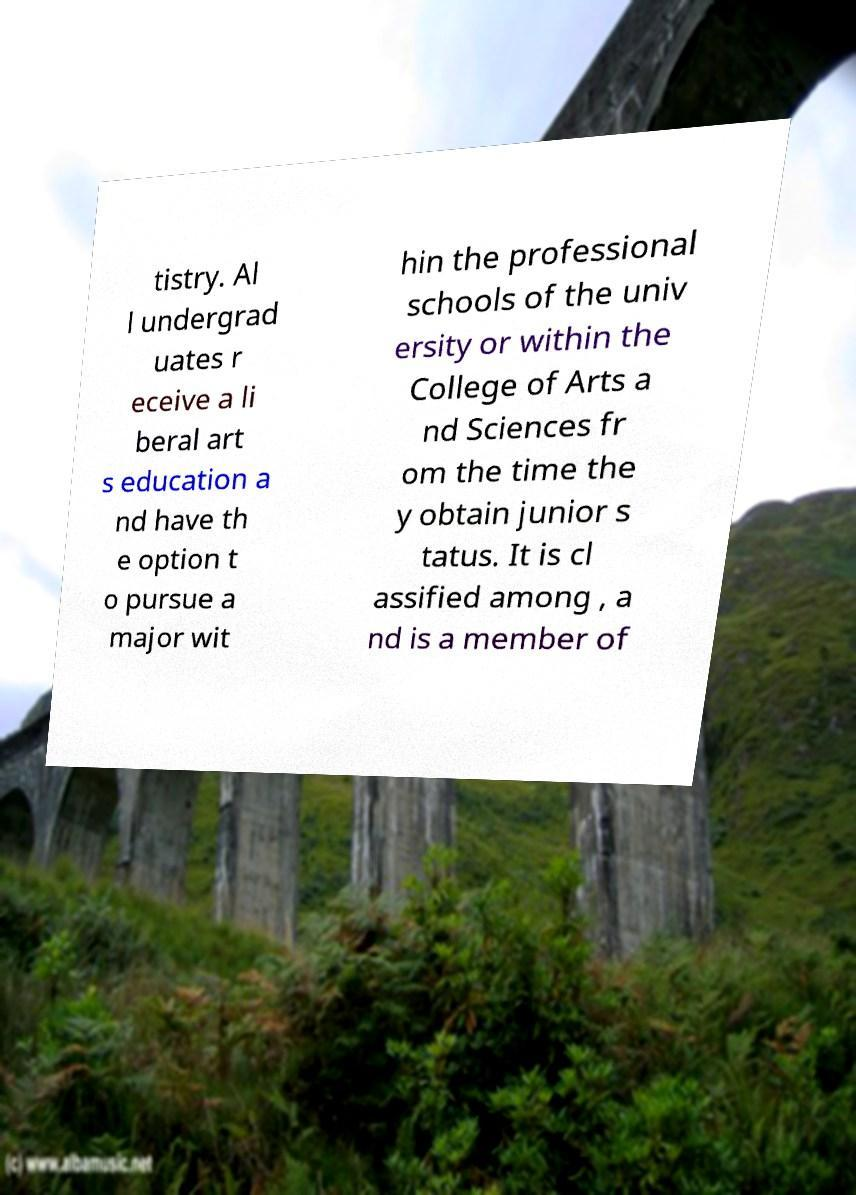For documentation purposes, I need the text within this image transcribed. Could you provide that? tistry. Al l undergrad uates r eceive a li beral art s education a nd have th e option t o pursue a major wit hin the professional schools of the univ ersity or within the College of Arts a nd Sciences fr om the time the y obtain junior s tatus. It is cl assified among , a nd is a member of 